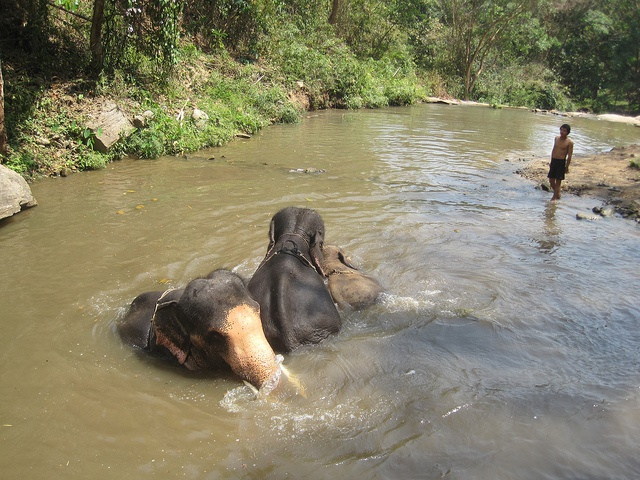Describe the objects in this image and their specific colors. I can see elephant in black, gray, and tan tones, elephant in black, gray, and tan tones, elephant in black, tan, and gray tones, and people in black, maroon, and darkgray tones in this image. 